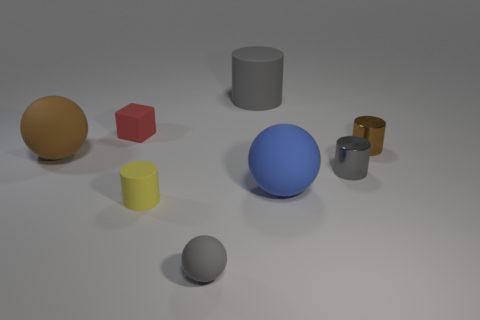Are any tiny yellow rubber cylinders visible? yes 